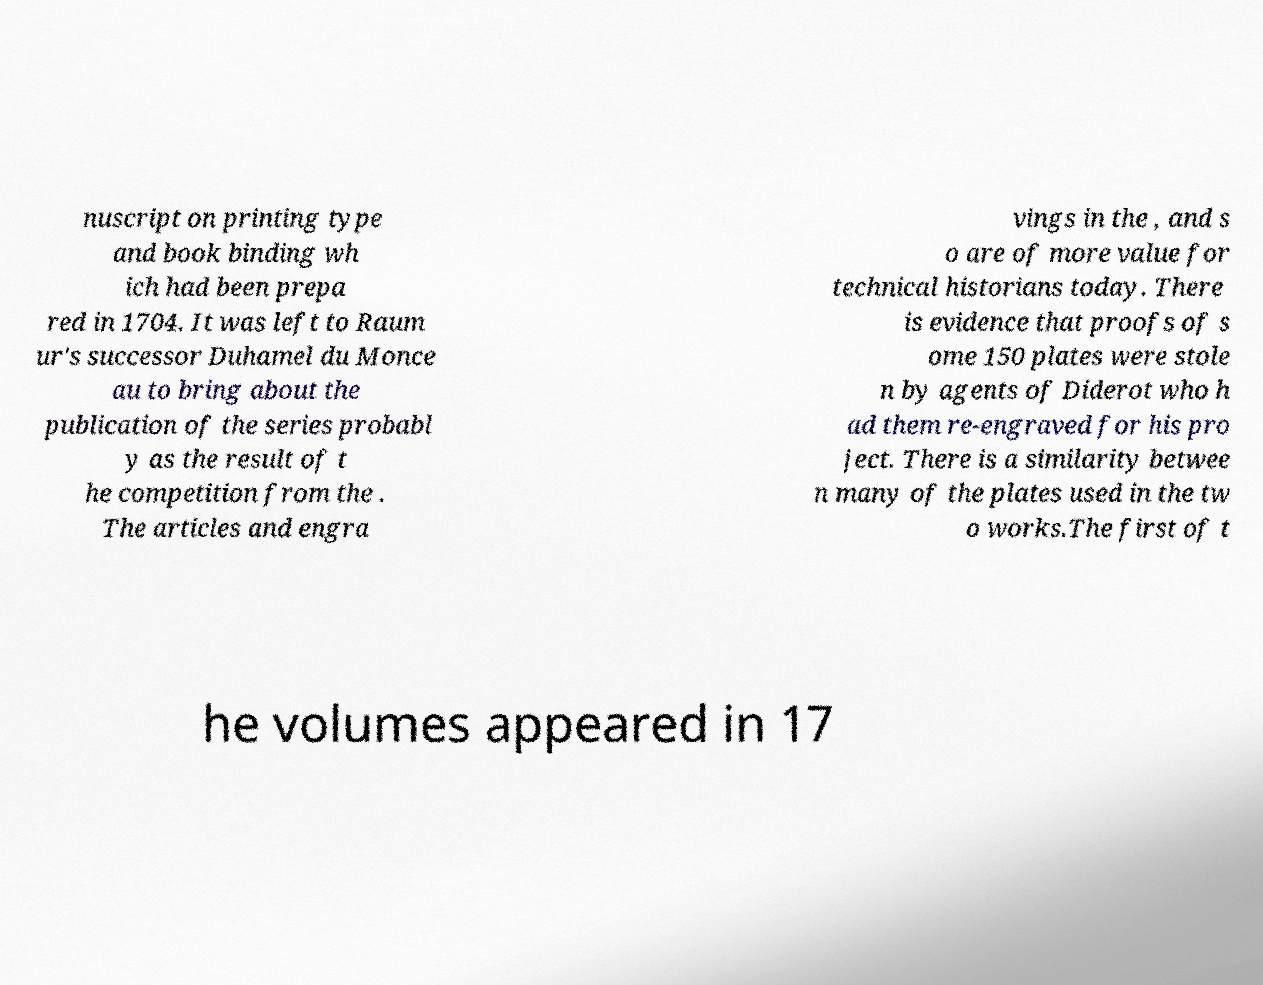Can you read and provide the text displayed in the image?This photo seems to have some interesting text. Can you extract and type it out for me? nuscript on printing type and book binding wh ich had been prepa red in 1704. It was left to Raum ur's successor Duhamel du Monce au to bring about the publication of the series probabl y as the result of t he competition from the . The articles and engra vings in the , and s o are of more value for technical historians today. There is evidence that proofs of s ome 150 plates were stole n by agents of Diderot who h ad them re-engraved for his pro ject. There is a similarity betwee n many of the plates used in the tw o works.The first of t he volumes appeared in 17 